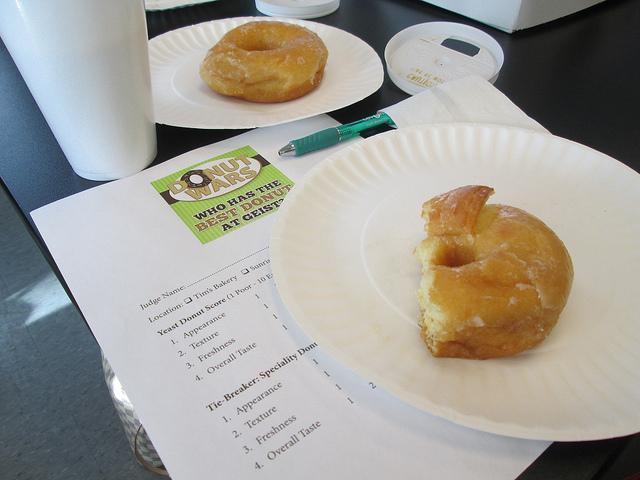How many glazed doughnuts are there?
Give a very brief answer. 2. How many power outlets are there?
Give a very brief answer. 0. How many donuts are on the plate?
Give a very brief answer. 1. How many donuts are there?
Give a very brief answer. 2. How many people are there?
Give a very brief answer. 0. 